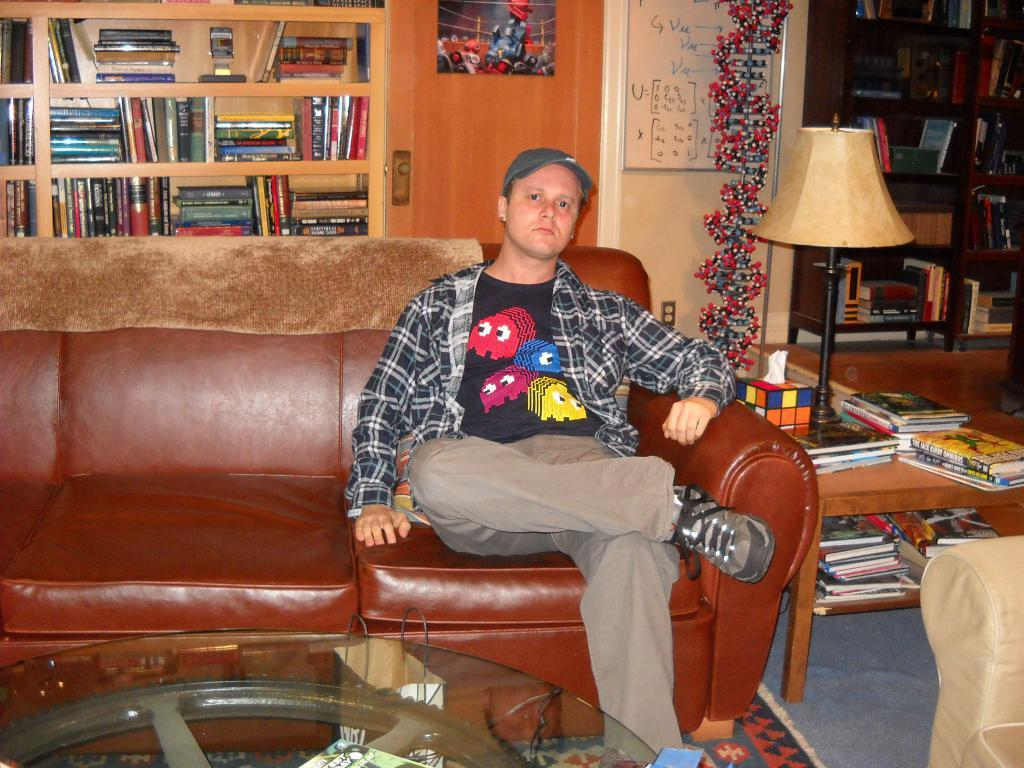What is the man in the image doing? The man is sitting on a sofa in the image. What is the man wearing on his head? The man is wearing a cap. What can be seen in the background of the image? There are books and a lamp in the background of the image. What effect does the lamp have on the family in the image? There is no family present in the image, and therefore no effect of the lamp on a family can be observed. 